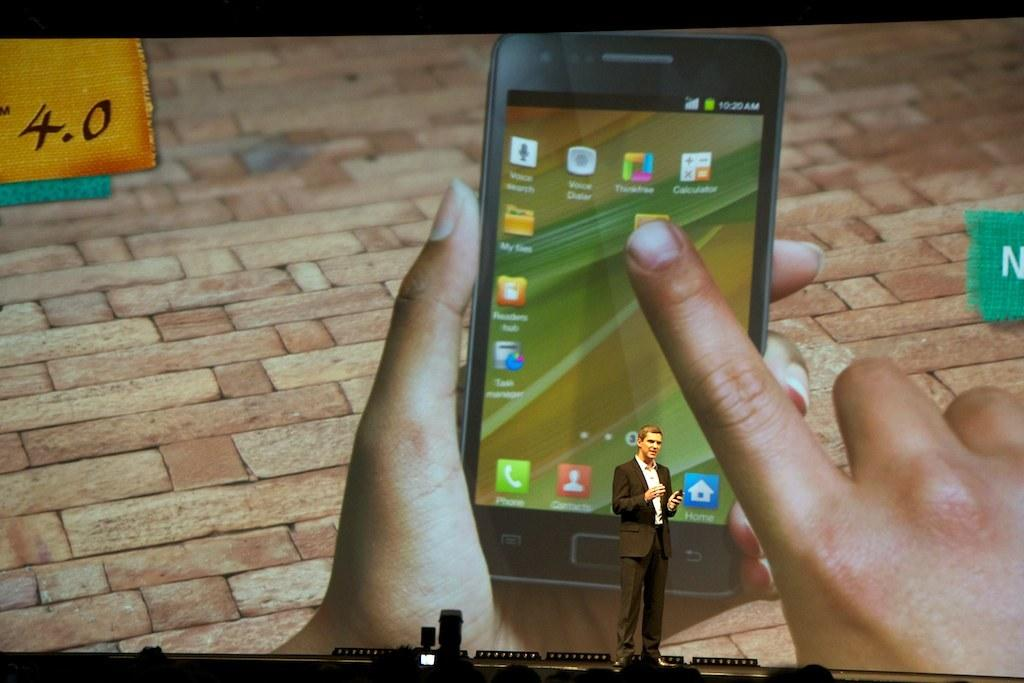<image>
Render a clear and concise summary of the photo. A man is giving a presentation with a screen showing someone holding phone with the time of 10:20 AM. 